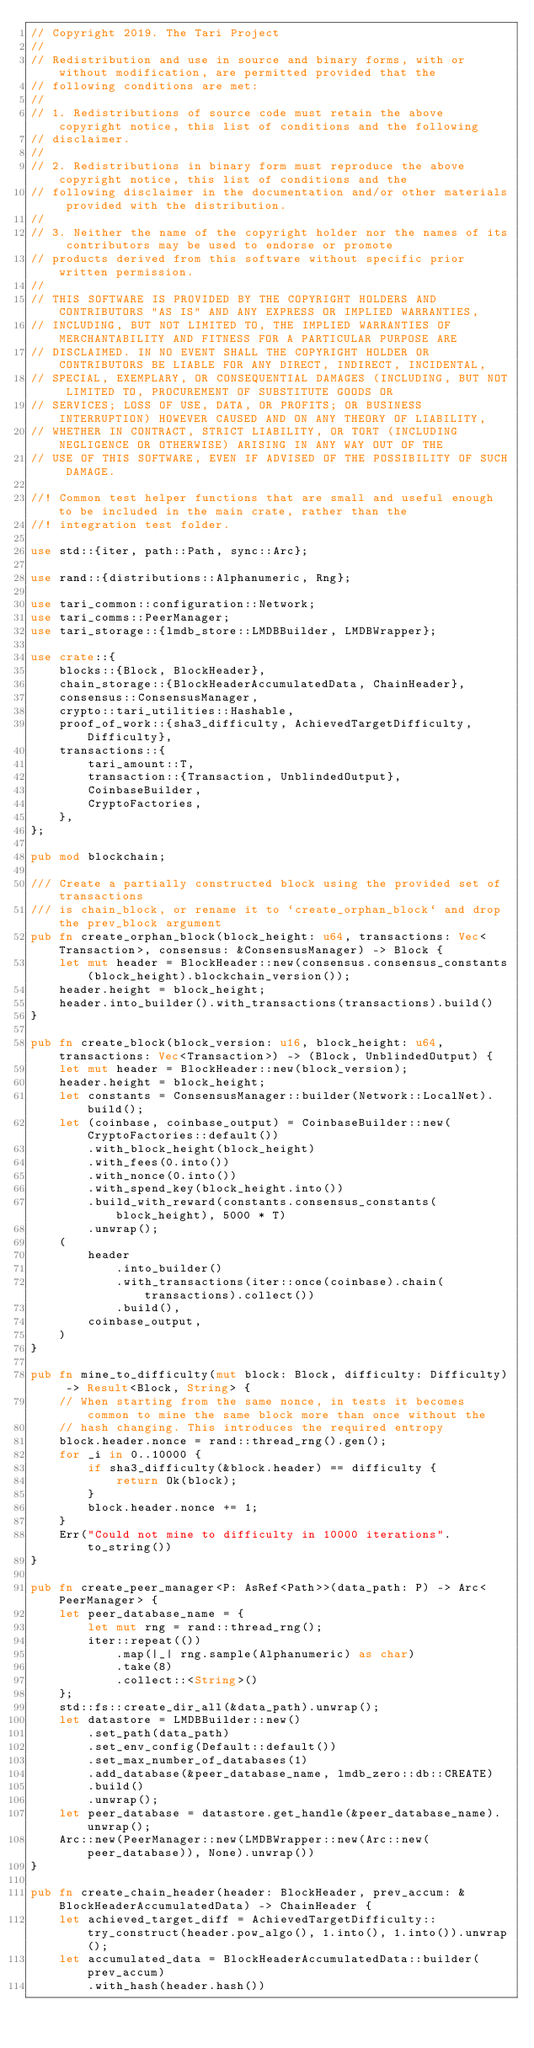Convert code to text. <code><loc_0><loc_0><loc_500><loc_500><_Rust_>// Copyright 2019. The Tari Project
//
// Redistribution and use in source and binary forms, with or without modification, are permitted provided that the
// following conditions are met:
//
// 1. Redistributions of source code must retain the above copyright notice, this list of conditions and the following
// disclaimer.
//
// 2. Redistributions in binary form must reproduce the above copyright notice, this list of conditions and the
// following disclaimer in the documentation and/or other materials provided with the distribution.
//
// 3. Neither the name of the copyright holder nor the names of its contributors may be used to endorse or promote
// products derived from this software without specific prior written permission.
//
// THIS SOFTWARE IS PROVIDED BY THE COPYRIGHT HOLDERS AND CONTRIBUTORS "AS IS" AND ANY EXPRESS OR IMPLIED WARRANTIES,
// INCLUDING, BUT NOT LIMITED TO, THE IMPLIED WARRANTIES OF MERCHANTABILITY AND FITNESS FOR A PARTICULAR PURPOSE ARE
// DISCLAIMED. IN NO EVENT SHALL THE COPYRIGHT HOLDER OR CONTRIBUTORS BE LIABLE FOR ANY DIRECT, INDIRECT, INCIDENTAL,
// SPECIAL, EXEMPLARY, OR CONSEQUENTIAL DAMAGES (INCLUDING, BUT NOT LIMITED TO, PROCUREMENT OF SUBSTITUTE GOODS OR
// SERVICES; LOSS OF USE, DATA, OR PROFITS; OR BUSINESS INTERRUPTION) HOWEVER CAUSED AND ON ANY THEORY OF LIABILITY,
// WHETHER IN CONTRACT, STRICT LIABILITY, OR TORT (INCLUDING NEGLIGENCE OR OTHERWISE) ARISING IN ANY WAY OUT OF THE
// USE OF THIS SOFTWARE, EVEN IF ADVISED OF THE POSSIBILITY OF SUCH DAMAGE.

//! Common test helper functions that are small and useful enough to be included in the main crate, rather than the
//! integration test folder.

use std::{iter, path::Path, sync::Arc};

use rand::{distributions::Alphanumeric, Rng};

use tari_common::configuration::Network;
use tari_comms::PeerManager;
use tari_storage::{lmdb_store::LMDBBuilder, LMDBWrapper};

use crate::{
    blocks::{Block, BlockHeader},
    chain_storage::{BlockHeaderAccumulatedData, ChainHeader},
    consensus::ConsensusManager,
    crypto::tari_utilities::Hashable,
    proof_of_work::{sha3_difficulty, AchievedTargetDifficulty, Difficulty},
    transactions::{
        tari_amount::T,
        transaction::{Transaction, UnblindedOutput},
        CoinbaseBuilder,
        CryptoFactories,
    },
};

pub mod blockchain;

/// Create a partially constructed block using the provided set of transactions
/// is chain_block, or rename it to `create_orphan_block` and drop the prev_block argument
pub fn create_orphan_block(block_height: u64, transactions: Vec<Transaction>, consensus: &ConsensusManager) -> Block {
    let mut header = BlockHeader::new(consensus.consensus_constants(block_height).blockchain_version());
    header.height = block_height;
    header.into_builder().with_transactions(transactions).build()
}

pub fn create_block(block_version: u16, block_height: u64, transactions: Vec<Transaction>) -> (Block, UnblindedOutput) {
    let mut header = BlockHeader::new(block_version);
    header.height = block_height;
    let constants = ConsensusManager::builder(Network::LocalNet).build();
    let (coinbase, coinbase_output) = CoinbaseBuilder::new(CryptoFactories::default())
        .with_block_height(block_height)
        .with_fees(0.into())
        .with_nonce(0.into())
        .with_spend_key(block_height.into())
        .build_with_reward(constants.consensus_constants(block_height), 5000 * T)
        .unwrap();
    (
        header
            .into_builder()
            .with_transactions(iter::once(coinbase).chain(transactions).collect())
            .build(),
        coinbase_output,
    )
}

pub fn mine_to_difficulty(mut block: Block, difficulty: Difficulty) -> Result<Block, String> {
    // When starting from the same nonce, in tests it becomes common to mine the same block more than once without the
    // hash changing. This introduces the required entropy
    block.header.nonce = rand::thread_rng().gen();
    for _i in 0..10000 {
        if sha3_difficulty(&block.header) == difficulty {
            return Ok(block);
        }
        block.header.nonce += 1;
    }
    Err("Could not mine to difficulty in 10000 iterations".to_string())
}

pub fn create_peer_manager<P: AsRef<Path>>(data_path: P) -> Arc<PeerManager> {
    let peer_database_name = {
        let mut rng = rand::thread_rng();
        iter::repeat(())
            .map(|_| rng.sample(Alphanumeric) as char)
            .take(8)
            .collect::<String>()
    };
    std::fs::create_dir_all(&data_path).unwrap();
    let datastore = LMDBBuilder::new()
        .set_path(data_path)
        .set_env_config(Default::default())
        .set_max_number_of_databases(1)
        .add_database(&peer_database_name, lmdb_zero::db::CREATE)
        .build()
        .unwrap();
    let peer_database = datastore.get_handle(&peer_database_name).unwrap();
    Arc::new(PeerManager::new(LMDBWrapper::new(Arc::new(peer_database)), None).unwrap())
}

pub fn create_chain_header(header: BlockHeader, prev_accum: &BlockHeaderAccumulatedData) -> ChainHeader {
    let achieved_target_diff = AchievedTargetDifficulty::try_construct(header.pow_algo(), 1.into(), 1.into()).unwrap();
    let accumulated_data = BlockHeaderAccumulatedData::builder(prev_accum)
        .with_hash(header.hash())</code> 